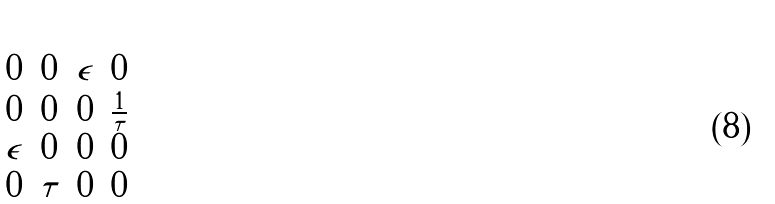<formula> <loc_0><loc_0><loc_500><loc_500>\begin{bmatrix} 0 & 0 & \epsilon & 0 \\ 0 & 0 & 0 & \frac { 1 } { \tau } \\ \epsilon & 0 & 0 & 0 \\ 0 & \tau & 0 & 0 \end{bmatrix}</formula> 